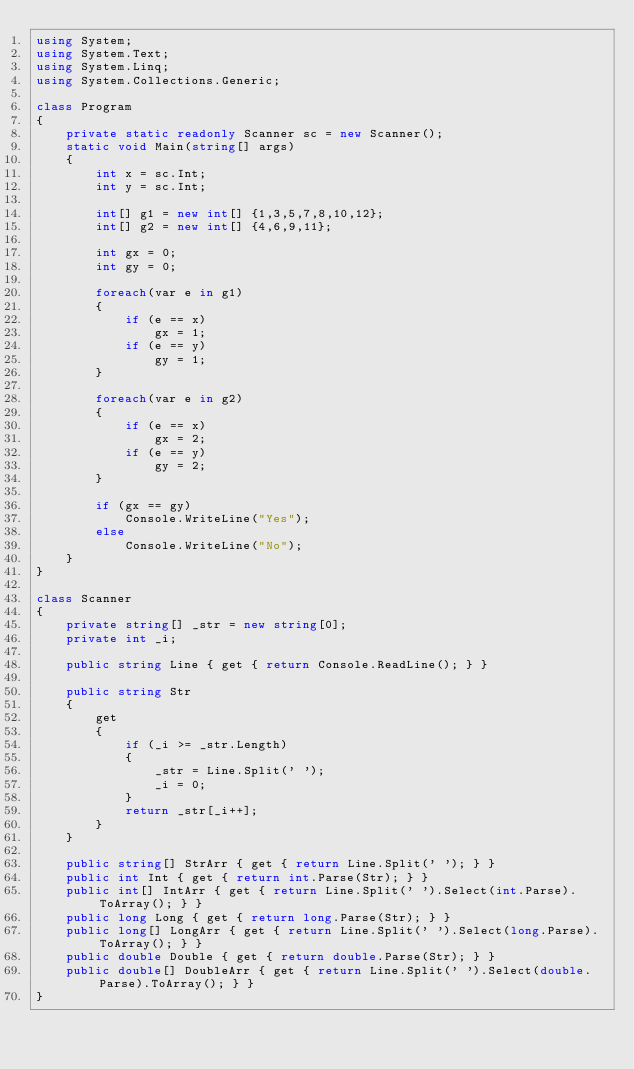Convert code to text. <code><loc_0><loc_0><loc_500><loc_500><_C#_>using System;
using System.Text;
using System.Linq;
using System.Collections.Generic;

class Program
{
    private static readonly Scanner sc = new Scanner();
    static void Main(string[] args)
    {
        int x = sc.Int;
        int y = sc.Int;

        int[] g1 = new int[] {1,3,5,7,8,10,12};
        int[] g2 = new int[] {4,6,9,11};

        int gx = 0;
        int gy = 0;

        foreach(var e in g1)
        {
            if (e == x)
                gx = 1;
            if (e == y)
                gy = 1;
        }

        foreach(var e in g2)
        {
            if (e == x)
                gx = 2;
            if (e == y)
                gy = 2;
        }

        if (gx == gy)
            Console.WriteLine("Yes");
        else
            Console.WriteLine("No");
    }
}

class Scanner
{
    private string[] _str = new string[0];
    private int _i;

    public string Line { get { return Console.ReadLine(); } }

    public string Str
    {
        get
        {
            if (_i >= _str.Length)
            {
                _str = Line.Split(' ');
                _i = 0;
            }
            return _str[_i++];
        }
    }

    public string[] StrArr { get { return Line.Split(' '); } }
    public int Int { get { return int.Parse(Str); } }
    public int[] IntArr { get { return Line.Split(' ').Select(int.Parse).ToArray(); } }
    public long Long { get { return long.Parse(Str); } }
    public long[] LongArr { get { return Line.Split(' ').Select(long.Parse).ToArray(); } }
    public double Double { get { return double.Parse(Str); } }
    public double[] DoubleArr { get { return Line.Split(' ').Select(double.Parse).ToArray(); } }
}</code> 